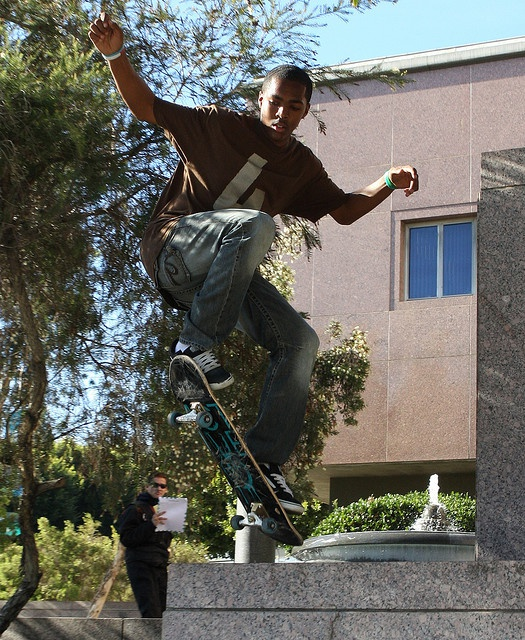Describe the objects in this image and their specific colors. I can see people in darkgreen, black, gray, maroon, and darkgray tones, skateboard in darkgreen, black, gray, and teal tones, and people in darkgreen, black, darkgray, and gray tones in this image. 